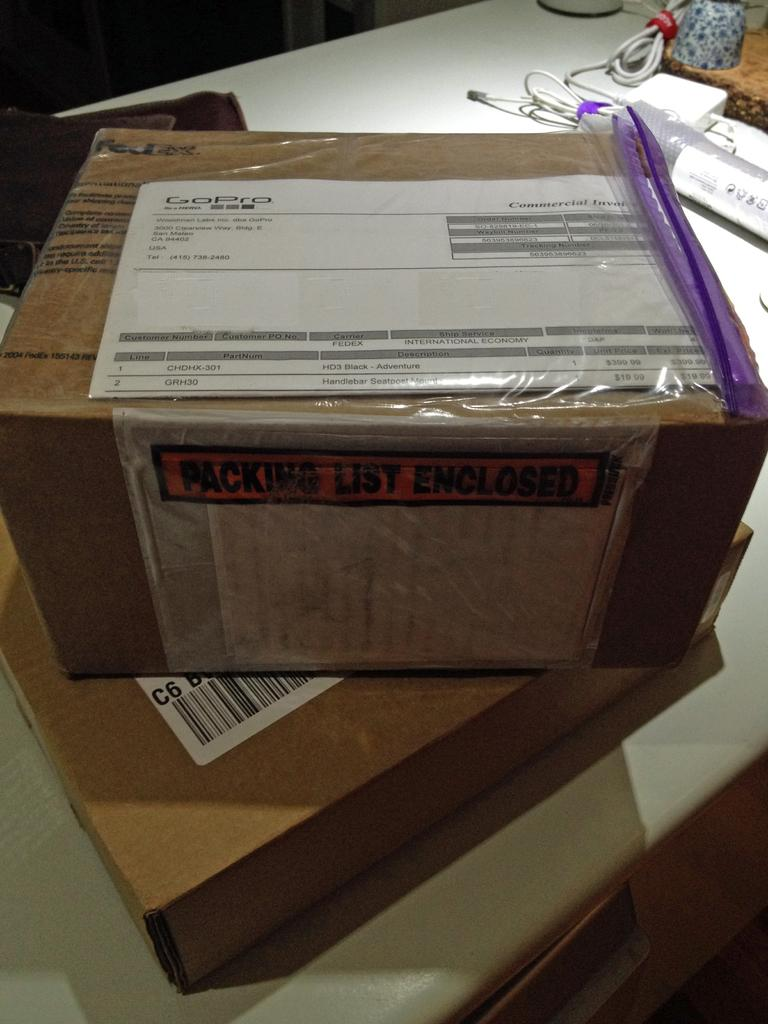<image>
Provide a brief description of the given image. Large brown box with an orange label that says "Packing List Enclosed". 